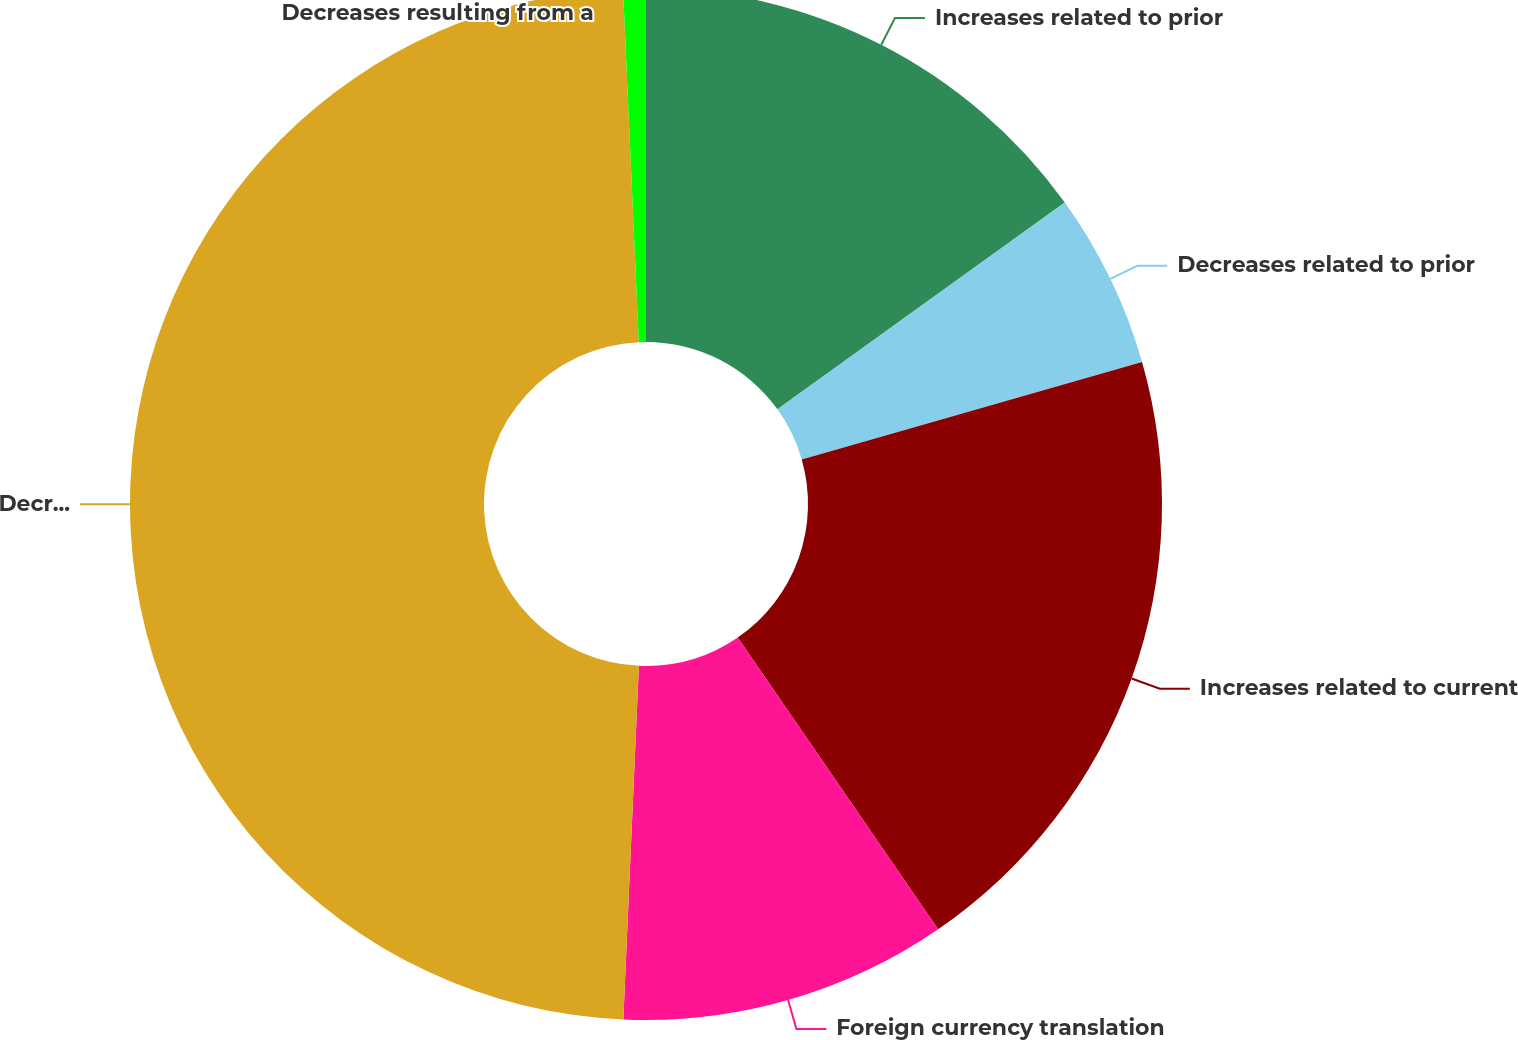Convert chart to OTSL. <chart><loc_0><loc_0><loc_500><loc_500><pie_chart><fcel>Increases related to prior<fcel>Decreases related to prior<fcel>Increases related to current<fcel>Foreign currency translation<fcel>Decreases relating to taxing<fcel>Decreases resulting from a<nl><fcel>15.07%<fcel>5.49%<fcel>19.86%<fcel>10.28%<fcel>48.59%<fcel>0.71%<nl></chart> 